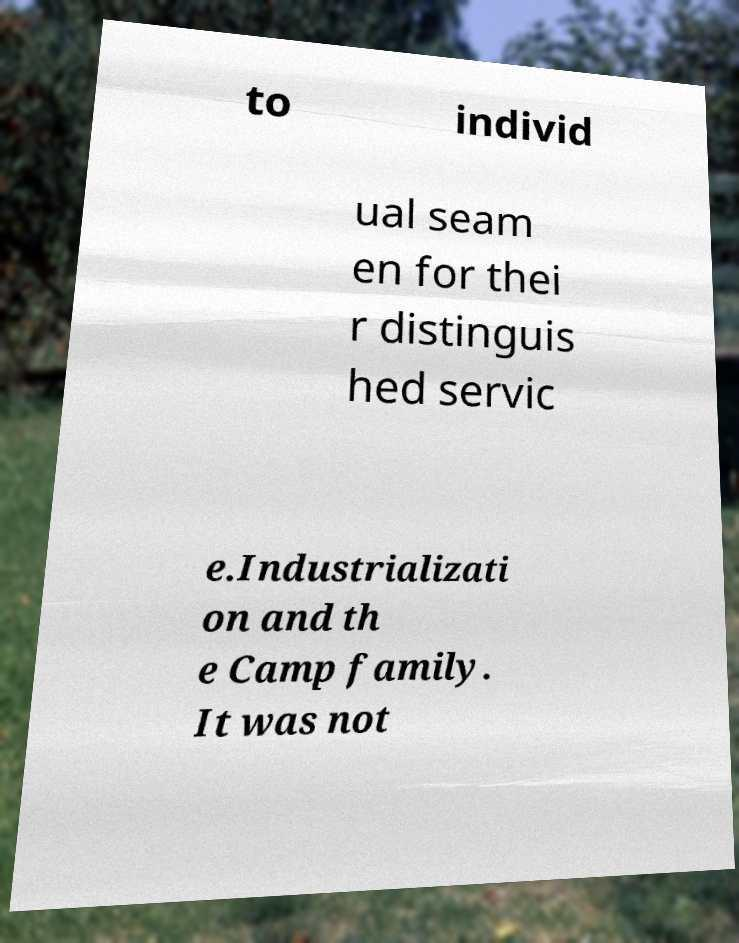I need the written content from this picture converted into text. Can you do that? to individ ual seam en for thei r distinguis hed servic e.Industrializati on and th e Camp family. It was not 